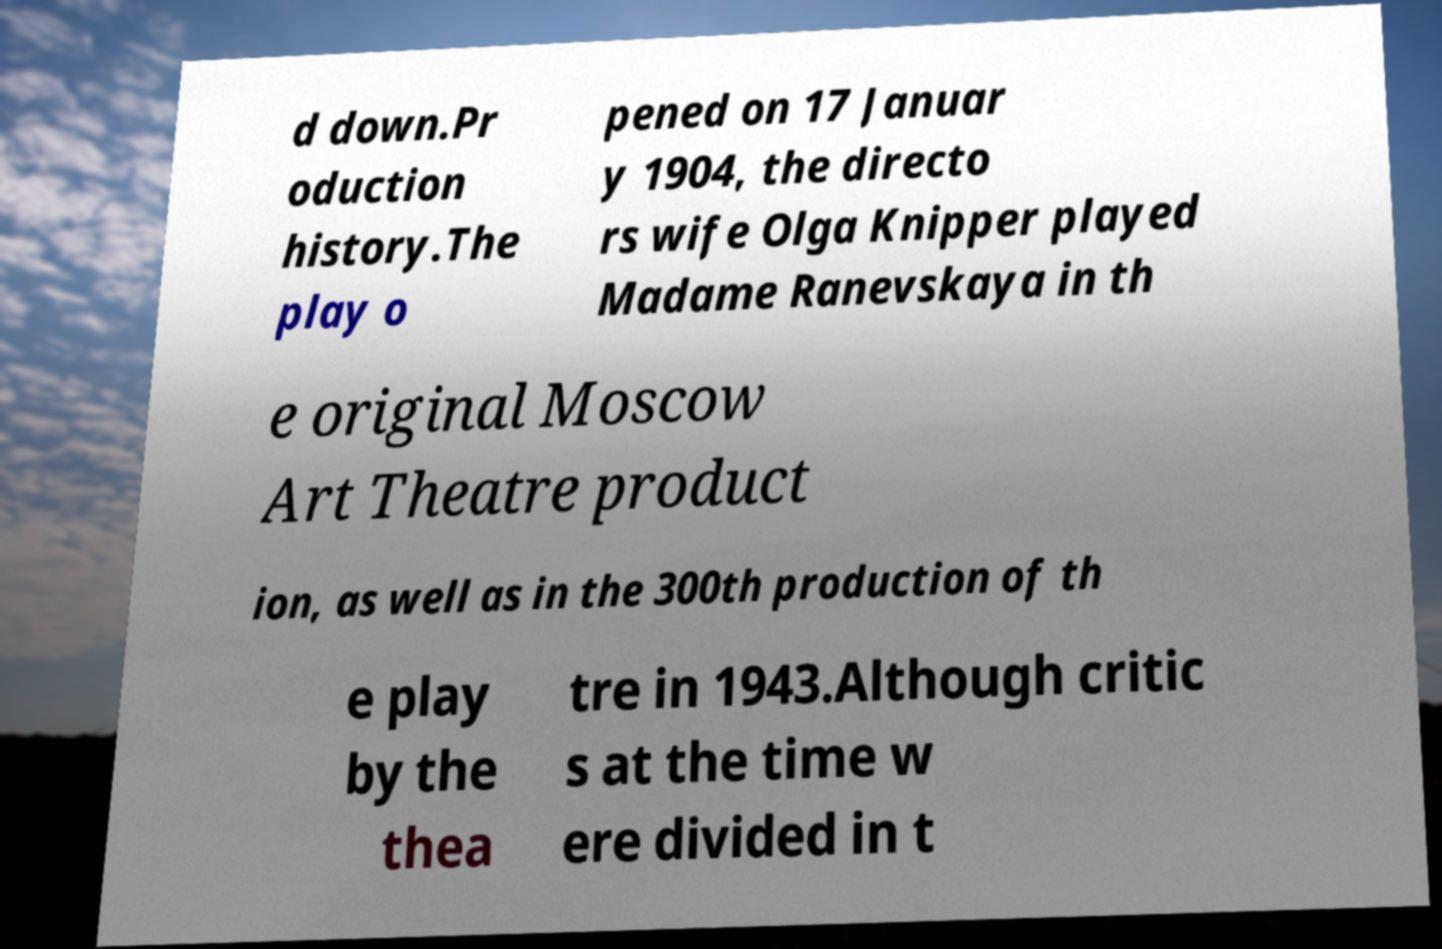For documentation purposes, I need the text within this image transcribed. Could you provide that? d down.Pr oduction history.The play o pened on 17 Januar y 1904, the directo rs wife Olga Knipper played Madame Ranevskaya in th e original Moscow Art Theatre product ion, as well as in the 300th production of th e play by the thea tre in 1943.Although critic s at the time w ere divided in t 